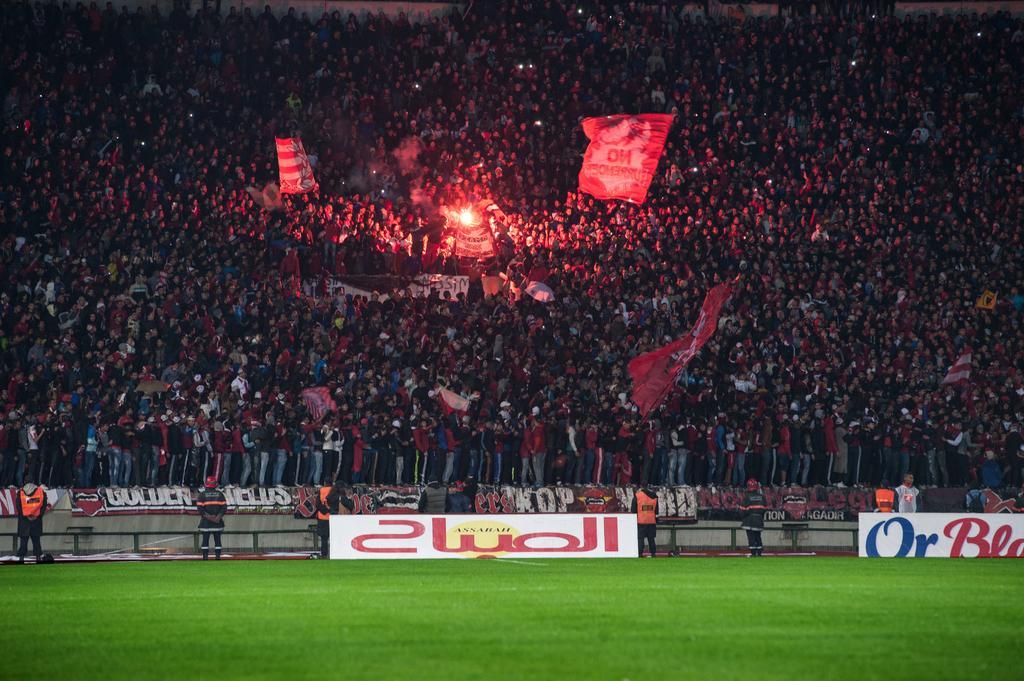Could you give a brief overview of what you see in this image? In this image I can see an open grass ground in the front. In the background I can see number of people are standing. I can also see few flags, few lights and on the bottom side of the image I can see number of boards. I can also see something is written on these boards. 